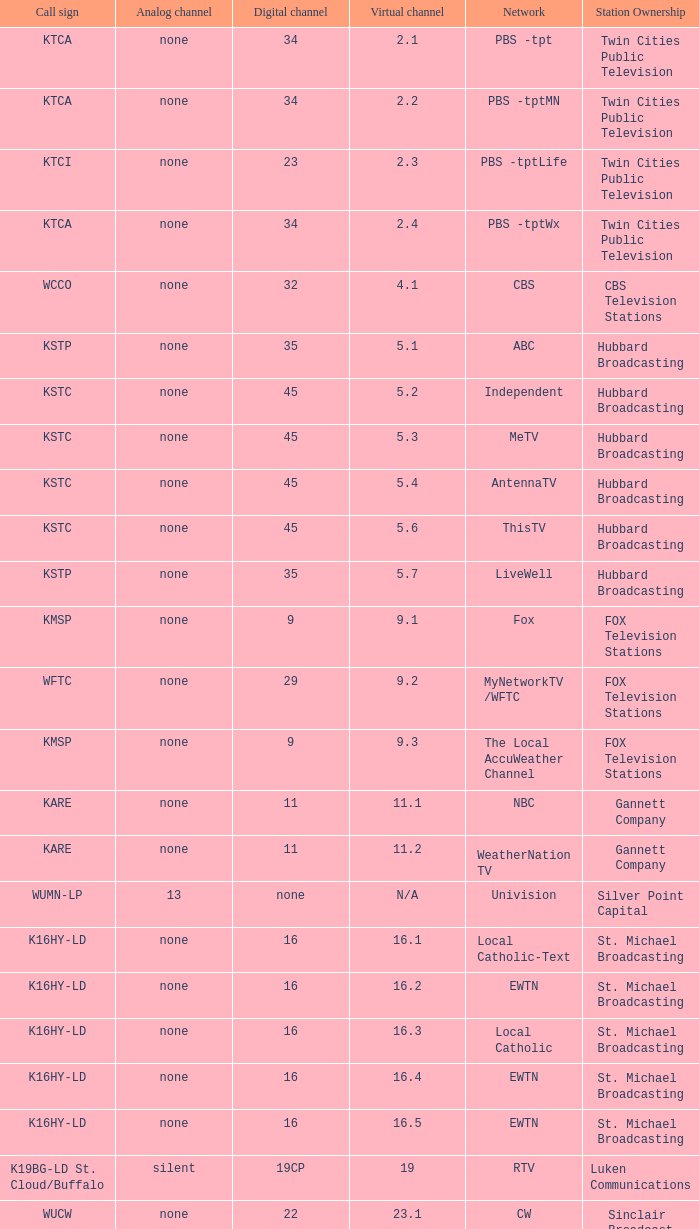Virtual channel of 16.5 has what call sign? K16HY-LD. 